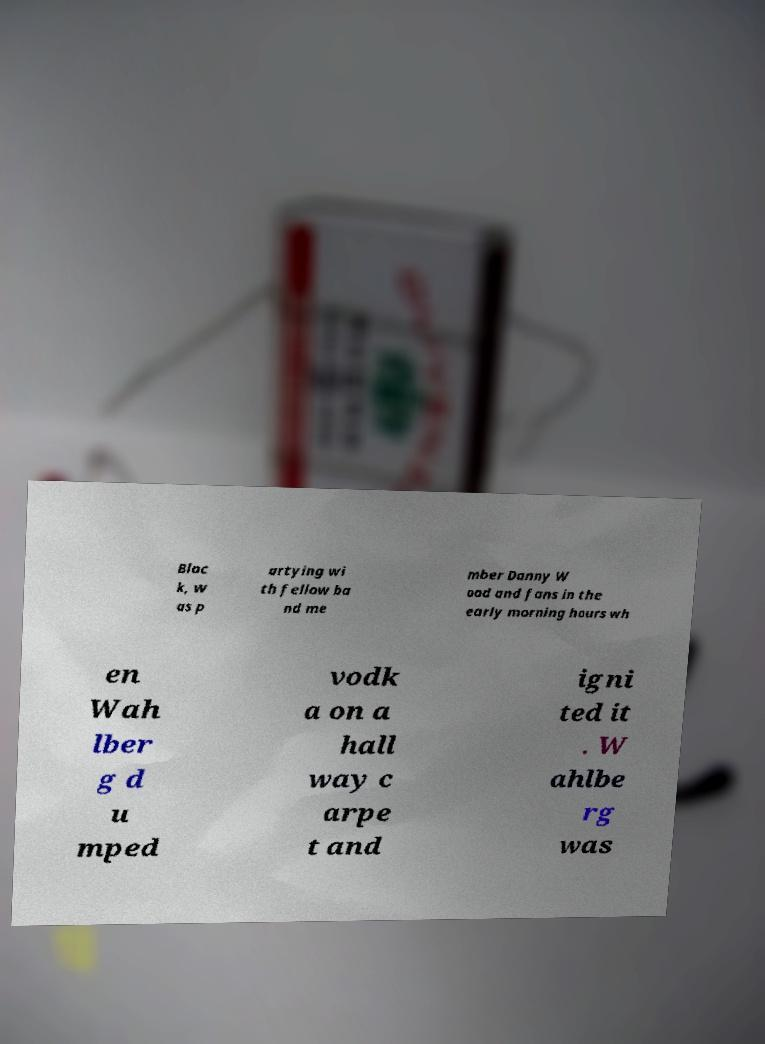What messages or text are displayed in this image? I need them in a readable, typed format. Bloc k, w as p artying wi th fellow ba nd me mber Danny W ood and fans in the early morning hours wh en Wah lber g d u mped vodk a on a hall way c arpe t and igni ted it . W ahlbe rg was 